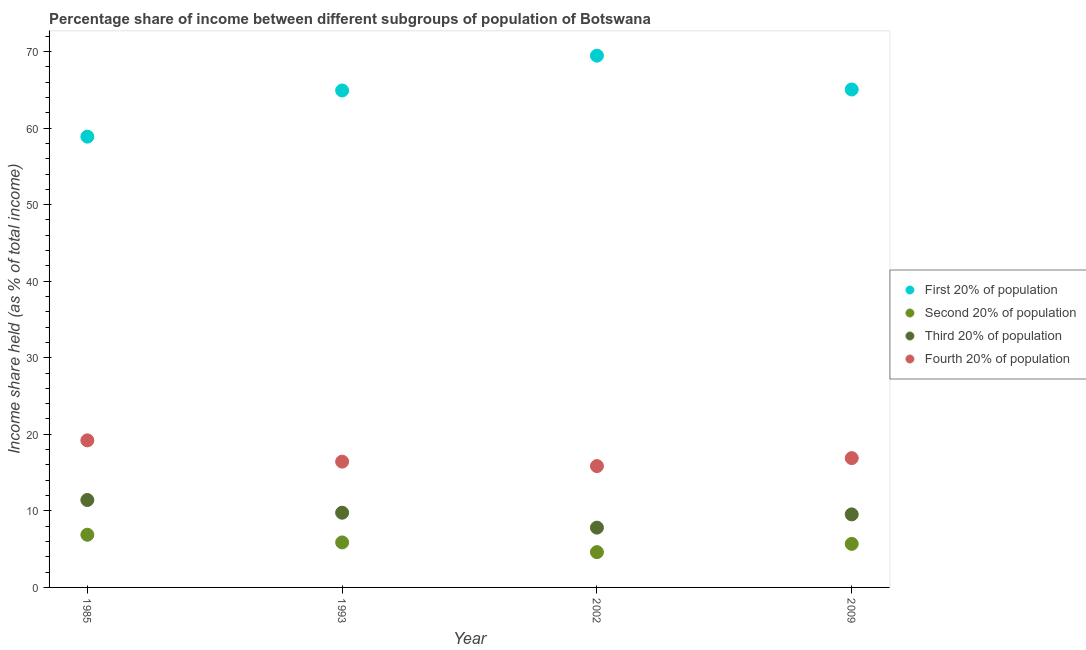Is the number of dotlines equal to the number of legend labels?
Your answer should be very brief. Yes. What is the share of the income held by first 20% of the population in 2002?
Offer a terse response. 69.46. Across all years, what is the maximum share of the income held by second 20% of the population?
Provide a short and direct response. 6.88. Across all years, what is the minimum share of the income held by first 20% of the population?
Offer a terse response. 58.88. In which year was the share of the income held by second 20% of the population maximum?
Keep it short and to the point. 1985. What is the total share of the income held by fourth 20% of the population in the graph?
Give a very brief answer. 68.38. What is the difference between the share of the income held by third 20% of the population in 1993 and that in 2002?
Your response must be concise. 1.95. What is the difference between the share of the income held by fourth 20% of the population in 1993 and the share of the income held by first 20% of the population in 2002?
Keep it short and to the point. -53.03. What is the average share of the income held by fourth 20% of the population per year?
Ensure brevity in your answer.  17.09. In the year 1985, what is the difference between the share of the income held by first 20% of the population and share of the income held by fourth 20% of the population?
Offer a terse response. 39.67. In how many years, is the share of the income held by third 20% of the population greater than 18 %?
Your answer should be compact. 0. What is the ratio of the share of the income held by third 20% of the population in 1985 to that in 1993?
Give a very brief answer. 1.17. What is the difference between the highest and the lowest share of the income held by second 20% of the population?
Your answer should be very brief. 2.27. In how many years, is the share of the income held by third 20% of the population greater than the average share of the income held by third 20% of the population taken over all years?
Your answer should be compact. 2. Is it the case that in every year, the sum of the share of the income held by first 20% of the population and share of the income held by second 20% of the population is greater than the share of the income held by third 20% of the population?
Provide a short and direct response. Yes. Does the share of the income held by first 20% of the population monotonically increase over the years?
Offer a very short reply. No. Is the share of the income held by first 20% of the population strictly greater than the share of the income held by third 20% of the population over the years?
Keep it short and to the point. Yes. What is the difference between two consecutive major ticks on the Y-axis?
Provide a succinct answer. 10. Does the graph contain any zero values?
Ensure brevity in your answer.  No. How many legend labels are there?
Your response must be concise. 4. How are the legend labels stacked?
Make the answer very short. Vertical. What is the title of the graph?
Keep it short and to the point. Percentage share of income between different subgroups of population of Botswana. Does "Taxes on revenue" appear as one of the legend labels in the graph?
Make the answer very short. No. What is the label or title of the Y-axis?
Keep it short and to the point. Income share held (as % of total income). What is the Income share held (as % of total income) of First 20% of population in 1985?
Your answer should be compact. 58.88. What is the Income share held (as % of total income) of Second 20% of population in 1985?
Your answer should be very brief. 6.88. What is the Income share held (as % of total income) in Third 20% of population in 1985?
Keep it short and to the point. 11.42. What is the Income share held (as % of total income) of Fourth 20% of population in 1985?
Your answer should be compact. 19.21. What is the Income share held (as % of total income) in First 20% of population in 1993?
Provide a short and direct response. 64.91. What is the Income share held (as % of total income) of Second 20% of population in 1993?
Your answer should be compact. 5.88. What is the Income share held (as % of total income) of Third 20% of population in 1993?
Provide a succinct answer. 9.76. What is the Income share held (as % of total income) in Fourth 20% of population in 1993?
Your response must be concise. 16.43. What is the Income share held (as % of total income) in First 20% of population in 2002?
Offer a terse response. 69.46. What is the Income share held (as % of total income) in Second 20% of population in 2002?
Your answer should be compact. 4.61. What is the Income share held (as % of total income) in Third 20% of population in 2002?
Make the answer very short. 7.81. What is the Income share held (as % of total income) of Fourth 20% of population in 2002?
Offer a terse response. 15.85. What is the Income share held (as % of total income) in First 20% of population in 2009?
Keep it short and to the point. 65.04. What is the Income share held (as % of total income) in Second 20% of population in 2009?
Provide a short and direct response. 5.69. What is the Income share held (as % of total income) in Third 20% of population in 2009?
Give a very brief answer. 9.54. What is the Income share held (as % of total income) of Fourth 20% of population in 2009?
Make the answer very short. 16.89. Across all years, what is the maximum Income share held (as % of total income) in First 20% of population?
Offer a very short reply. 69.46. Across all years, what is the maximum Income share held (as % of total income) of Second 20% of population?
Make the answer very short. 6.88. Across all years, what is the maximum Income share held (as % of total income) of Third 20% of population?
Your answer should be very brief. 11.42. Across all years, what is the maximum Income share held (as % of total income) of Fourth 20% of population?
Keep it short and to the point. 19.21. Across all years, what is the minimum Income share held (as % of total income) of First 20% of population?
Ensure brevity in your answer.  58.88. Across all years, what is the minimum Income share held (as % of total income) of Second 20% of population?
Provide a succinct answer. 4.61. Across all years, what is the minimum Income share held (as % of total income) of Third 20% of population?
Your answer should be compact. 7.81. Across all years, what is the minimum Income share held (as % of total income) in Fourth 20% of population?
Give a very brief answer. 15.85. What is the total Income share held (as % of total income) of First 20% of population in the graph?
Your answer should be very brief. 258.29. What is the total Income share held (as % of total income) in Second 20% of population in the graph?
Make the answer very short. 23.06. What is the total Income share held (as % of total income) of Third 20% of population in the graph?
Give a very brief answer. 38.53. What is the total Income share held (as % of total income) in Fourth 20% of population in the graph?
Your response must be concise. 68.38. What is the difference between the Income share held (as % of total income) of First 20% of population in 1985 and that in 1993?
Your answer should be very brief. -6.03. What is the difference between the Income share held (as % of total income) of Second 20% of population in 1985 and that in 1993?
Provide a succinct answer. 1. What is the difference between the Income share held (as % of total income) of Third 20% of population in 1985 and that in 1993?
Ensure brevity in your answer.  1.66. What is the difference between the Income share held (as % of total income) of Fourth 20% of population in 1985 and that in 1993?
Keep it short and to the point. 2.78. What is the difference between the Income share held (as % of total income) in First 20% of population in 1985 and that in 2002?
Your answer should be compact. -10.58. What is the difference between the Income share held (as % of total income) of Second 20% of population in 1985 and that in 2002?
Give a very brief answer. 2.27. What is the difference between the Income share held (as % of total income) in Third 20% of population in 1985 and that in 2002?
Your response must be concise. 3.61. What is the difference between the Income share held (as % of total income) of Fourth 20% of population in 1985 and that in 2002?
Make the answer very short. 3.36. What is the difference between the Income share held (as % of total income) in First 20% of population in 1985 and that in 2009?
Your answer should be compact. -6.16. What is the difference between the Income share held (as % of total income) in Second 20% of population in 1985 and that in 2009?
Your answer should be very brief. 1.19. What is the difference between the Income share held (as % of total income) in Third 20% of population in 1985 and that in 2009?
Your answer should be very brief. 1.88. What is the difference between the Income share held (as % of total income) of Fourth 20% of population in 1985 and that in 2009?
Your answer should be compact. 2.32. What is the difference between the Income share held (as % of total income) in First 20% of population in 1993 and that in 2002?
Your response must be concise. -4.55. What is the difference between the Income share held (as % of total income) in Second 20% of population in 1993 and that in 2002?
Your answer should be very brief. 1.27. What is the difference between the Income share held (as % of total income) in Third 20% of population in 1993 and that in 2002?
Offer a terse response. 1.95. What is the difference between the Income share held (as % of total income) of Fourth 20% of population in 1993 and that in 2002?
Offer a very short reply. 0.58. What is the difference between the Income share held (as % of total income) in First 20% of population in 1993 and that in 2009?
Keep it short and to the point. -0.13. What is the difference between the Income share held (as % of total income) of Second 20% of population in 1993 and that in 2009?
Make the answer very short. 0.19. What is the difference between the Income share held (as % of total income) in Third 20% of population in 1993 and that in 2009?
Keep it short and to the point. 0.22. What is the difference between the Income share held (as % of total income) in Fourth 20% of population in 1993 and that in 2009?
Provide a succinct answer. -0.46. What is the difference between the Income share held (as % of total income) in First 20% of population in 2002 and that in 2009?
Your response must be concise. 4.42. What is the difference between the Income share held (as % of total income) in Second 20% of population in 2002 and that in 2009?
Ensure brevity in your answer.  -1.08. What is the difference between the Income share held (as % of total income) in Third 20% of population in 2002 and that in 2009?
Offer a terse response. -1.73. What is the difference between the Income share held (as % of total income) of Fourth 20% of population in 2002 and that in 2009?
Keep it short and to the point. -1.04. What is the difference between the Income share held (as % of total income) of First 20% of population in 1985 and the Income share held (as % of total income) of Second 20% of population in 1993?
Your answer should be very brief. 53. What is the difference between the Income share held (as % of total income) in First 20% of population in 1985 and the Income share held (as % of total income) in Third 20% of population in 1993?
Provide a short and direct response. 49.12. What is the difference between the Income share held (as % of total income) in First 20% of population in 1985 and the Income share held (as % of total income) in Fourth 20% of population in 1993?
Offer a terse response. 42.45. What is the difference between the Income share held (as % of total income) of Second 20% of population in 1985 and the Income share held (as % of total income) of Third 20% of population in 1993?
Offer a very short reply. -2.88. What is the difference between the Income share held (as % of total income) of Second 20% of population in 1985 and the Income share held (as % of total income) of Fourth 20% of population in 1993?
Provide a succinct answer. -9.55. What is the difference between the Income share held (as % of total income) of Third 20% of population in 1985 and the Income share held (as % of total income) of Fourth 20% of population in 1993?
Provide a succinct answer. -5.01. What is the difference between the Income share held (as % of total income) of First 20% of population in 1985 and the Income share held (as % of total income) of Second 20% of population in 2002?
Make the answer very short. 54.27. What is the difference between the Income share held (as % of total income) of First 20% of population in 1985 and the Income share held (as % of total income) of Third 20% of population in 2002?
Keep it short and to the point. 51.07. What is the difference between the Income share held (as % of total income) of First 20% of population in 1985 and the Income share held (as % of total income) of Fourth 20% of population in 2002?
Ensure brevity in your answer.  43.03. What is the difference between the Income share held (as % of total income) of Second 20% of population in 1985 and the Income share held (as % of total income) of Third 20% of population in 2002?
Keep it short and to the point. -0.93. What is the difference between the Income share held (as % of total income) in Second 20% of population in 1985 and the Income share held (as % of total income) in Fourth 20% of population in 2002?
Your answer should be compact. -8.97. What is the difference between the Income share held (as % of total income) in Third 20% of population in 1985 and the Income share held (as % of total income) in Fourth 20% of population in 2002?
Offer a very short reply. -4.43. What is the difference between the Income share held (as % of total income) in First 20% of population in 1985 and the Income share held (as % of total income) in Second 20% of population in 2009?
Ensure brevity in your answer.  53.19. What is the difference between the Income share held (as % of total income) in First 20% of population in 1985 and the Income share held (as % of total income) in Third 20% of population in 2009?
Your answer should be compact. 49.34. What is the difference between the Income share held (as % of total income) in First 20% of population in 1985 and the Income share held (as % of total income) in Fourth 20% of population in 2009?
Give a very brief answer. 41.99. What is the difference between the Income share held (as % of total income) of Second 20% of population in 1985 and the Income share held (as % of total income) of Third 20% of population in 2009?
Give a very brief answer. -2.66. What is the difference between the Income share held (as % of total income) in Second 20% of population in 1985 and the Income share held (as % of total income) in Fourth 20% of population in 2009?
Keep it short and to the point. -10.01. What is the difference between the Income share held (as % of total income) in Third 20% of population in 1985 and the Income share held (as % of total income) in Fourth 20% of population in 2009?
Keep it short and to the point. -5.47. What is the difference between the Income share held (as % of total income) of First 20% of population in 1993 and the Income share held (as % of total income) of Second 20% of population in 2002?
Ensure brevity in your answer.  60.3. What is the difference between the Income share held (as % of total income) in First 20% of population in 1993 and the Income share held (as % of total income) in Third 20% of population in 2002?
Your response must be concise. 57.1. What is the difference between the Income share held (as % of total income) in First 20% of population in 1993 and the Income share held (as % of total income) in Fourth 20% of population in 2002?
Your answer should be compact. 49.06. What is the difference between the Income share held (as % of total income) in Second 20% of population in 1993 and the Income share held (as % of total income) in Third 20% of population in 2002?
Your response must be concise. -1.93. What is the difference between the Income share held (as % of total income) of Second 20% of population in 1993 and the Income share held (as % of total income) of Fourth 20% of population in 2002?
Provide a succinct answer. -9.97. What is the difference between the Income share held (as % of total income) of Third 20% of population in 1993 and the Income share held (as % of total income) of Fourth 20% of population in 2002?
Your response must be concise. -6.09. What is the difference between the Income share held (as % of total income) in First 20% of population in 1993 and the Income share held (as % of total income) in Second 20% of population in 2009?
Your answer should be compact. 59.22. What is the difference between the Income share held (as % of total income) in First 20% of population in 1993 and the Income share held (as % of total income) in Third 20% of population in 2009?
Provide a short and direct response. 55.37. What is the difference between the Income share held (as % of total income) in First 20% of population in 1993 and the Income share held (as % of total income) in Fourth 20% of population in 2009?
Your answer should be compact. 48.02. What is the difference between the Income share held (as % of total income) of Second 20% of population in 1993 and the Income share held (as % of total income) of Third 20% of population in 2009?
Offer a terse response. -3.66. What is the difference between the Income share held (as % of total income) in Second 20% of population in 1993 and the Income share held (as % of total income) in Fourth 20% of population in 2009?
Provide a succinct answer. -11.01. What is the difference between the Income share held (as % of total income) in Third 20% of population in 1993 and the Income share held (as % of total income) in Fourth 20% of population in 2009?
Keep it short and to the point. -7.13. What is the difference between the Income share held (as % of total income) in First 20% of population in 2002 and the Income share held (as % of total income) in Second 20% of population in 2009?
Your response must be concise. 63.77. What is the difference between the Income share held (as % of total income) of First 20% of population in 2002 and the Income share held (as % of total income) of Third 20% of population in 2009?
Ensure brevity in your answer.  59.92. What is the difference between the Income share held (as % of total income) of First 20% of population in 2002 and the Income share held (as % of total income) of Fourth 20% of population in 2009?
Offer a terse response. 52.57. What is the difference between the Income share held (as % of total income) of Second 20% of population in 2002 and the Income share held (as % of total income) of Third 20% of population in 2009?
Keep it short and to the point. -4.93. What is the difference between the Income share held (as % of total income) in Second 20% of population in 2002 and the Income share held (as % of total income) in Fourth 20% of population in 2009?
Offer a very short reply. -12.28. What is the difference between the Income share held (as % of total income) of Third 20% of population in 2002 and the Income share held (as % of total income) of Fourth 20% of population in 2009?
Provide a succinct answer. -9.08. What is the average Income share held (as % of total income) of First 20% of population per year?
Provide a short and direct response. 64.57. What is the average Income share held (as % of total income) in Second 20% of population per year?
Keep it short and to the point. 5.76. What is the average Income share held (as % of total income) of Third 20% of population per year?
Make the answer very short. 9.63. What is the average Income share held (as % of total income) in Fourth 20% of population per year?
Offer a very short reply. 17.09. In the year 1985, what is the difference between the Income share held (as % of total income) in First 20% of population and Income share held (as % of total income) in Second 20% of population?
Provide a short and direct response. 52. In the year 1985, what is the difference between the Income share held (as % of total income) in First 20% of population and Income share held (as % of total income) in Third 20% of population?
Provide a short and direct response. 47.46. In the year 1985, what is the difference between the Income share held (as % of total income) of First 20% of population and Income share held (as % of total income) of Fourth 20% of population?
Give a very brief answer. 39.67. In the year 1985, what is the difference between the Income share held (as % of total income) in Second 20% of population and Income share held (as % of total income) in Third 20% of population?
Your response must be concise. -4.54. In the year 1985, what is the difference between the Income share held (as % of total income) of Second 20% of population and Income share held (as % of total income) of Fourth 20% of population?
Your response must be concise. -12.33. In the year 1985, what is the difference between the Income share held (as % of total income) of Third 20% of population and Income share held (as % of total income) of Fourth 20% of population?
Make the answer very short. -7.79. In the year 1993, what is the difference between the Income share held (as % of total income) in First 20% of population and Income share held (as % of total income) in Second 20% of population?
Keep it short and to the point. 59.03. In the year 1993, what is the difference between the Income share held (as % of total income) in First 20% of population and Income share held (as % of total income) in Third 20% of population?
Give a very brief answer. 55.15. In the year 1993, what is the difference between the Income share held (as % of total income) of First 20% of population and Income share held (as % of total income) of Fourth 20% of population?
Provide a short and direct response. 48.48. In the year 1993, what is the difference between the Income share held (as % of total income) of Second 20% of population and Income share held (as % of total income) of Third 20% of population?
Offer a very short reply. -3.88. In the year 1993, what is the difference between the Income share held (as % of total income) of Second 20% of population and Income share held (as % of total income) of Fourth 20% of population?
Your answer should be very brief. -10.55. In the year 1993, what is the difference between the Income share held (as % of total income) of Third 20% of population and Income share held (as % of total income) of Fourth 20% of population?
Keep it short and to the point. -6.67. In the year 2002, what is the difference between the Income share held (as % of total income) in First 20% of population and Income share held (as % of total income) in Second 20% of population?
Offer a very short reply. 64.85. In the year 2002, what is the difference between the Income share held (as % of total income) in First 20% of population and Income share held (as % of total income) in Third 20% of population?
Ensure brevity in your answer.  61.65. In the year 2002, what is the difference between the Income share held (as % of total income) of First 20% of population and Income share held (as % of total income) of Fourth 20% of population?
Give a very brief answer. 53.61. In the year 2002, what is the difference between the Income share held (as % of total income) in Second 20% of population and Income share held (as % of total income) in Third 20% of population?
Your answer should be very brief. -3.2. In the year 2002, what is the difference between the Income share held (as % of total income) in Second 20% of population and Income share held (as % of total income) in Fourth 20% of population?
Offer a very short reply. -11.24. In the year 2002, what is the difference between the Income share held (as % of total income) of Third 20% of population and Income share held (as % of total income) of Fourth 20% of population?
Provide a short and direct response. -8.04. In the year 2009, what is the difference between the Income share held (as % of total income) of First 20% of population and Income share held (as % of total income) of Second 20% of population?
Make the answer very short. 59.35. In the year 2009, what is the difference between the Income share held (as % of total income) of First 20% of population and Income share held (as % of total income) of Third 20% of population?
Ensure brevity in your answer.  55.5. In the year 2009, what is the difference between the Income share held (as % of total income) in First 20% of population and Income share held (as % of total income) in Fourth 20% of population?
Provide a succinct answer. 48.15. In the year 2009, what is the difference between the Income share held (as % of total income) in Second 20% of population and Income share held (as % of total income) in Third 20% of population?
Your response must be concise. -3.85. In the year 2009, what is the difference between the Income share held (as % of total income) of Third 20% of population and Income share held (as % of total income) of Fourth 20% of population?
Your answer should be compact. -7.35. What is the ratio of the Income share held (as % of total income) of First 20% of population in 1985 to that in 1993?
Offer a very short reply. 0.91. What is the ratio of the Income share held (as % of total income) in Second 20% of population in 1985 to that in 1993?
Provide a short and direct response. 1.17. What is the ratio of the Income share held (as % of total income) in Third 20% of population in 1985 to that in 1993?
Your answer should be compact. 1.17. What is the ratio of the Income share held (as % of total income) of Fourth 20% of population in 1985 to that in 1993?
Offer a very short reply. 1.17. What is the ratio of the Income share held (as % of total income) of First 20% of population in 1985 to that in 2002?
Keep it short and to the point. 0.85. What is the ratio of the Income share held (as % of total income) of Second 20% of population in 1985 to that in 2002?
Provide a succinct answer. 1.49. What is the ratio of the Income share held (as % of total income) in Third 20% of population in 1985 to that in 2002?
Ensure brevity in your answer.  1.46. What is the ratio of the Income share held (as % of total income) in Fourth 20% of population in 1985 to that in 2002?
Your response must be concise. 1.21. What is the ratio of the Income share held (as % of total income) of First 20% of population in 1985 to that in 2009?
Your answer should be compact. 0.91. What is the ratio of the Income share held (as % of total income) of Second 20% of population in 1985 to that in 2009?
Provide a short and direct response. 1.21. What is the ratio of the Income share held (as % of total income) in Third 20% of population in 1985 to that in 2009?
Make the answer very short. 1.2. What is the ratio of the Income share held (as % of total income) in Fourth 20% of population in 1985 to that in 2009?
Provide a succinct answer. 1.14. What is the ratio of the Income share held (as % of total income) in First 20% of population in 1993 to that in 2002?
Give a very brief answer. 0.93. What is the ratio of the Income share held (as % of total income) in Second 20% of population in 1993 to that in 2002?
Provide a succinct answer. 1.28. What is the ratio of the Income share held (as % of total income) of Third 20% of population in 1993 to that in 2002?
Offer a very short reply. 1.25. What is the ratio of the Income share held (as % of total income) in Fourth 20% of population in 1993 to that in 2002?
Provide a short and direct response. 1.04. What is the ratio of the Income share held (as % of total income) of First 20% of population in 1993 to that in 2009?
Keep it short and to the point. 1. What is the ratio of the Income share held (as % of total income) of Second 20% of population in 1993 to that in 2009?
Provide a short and direct response. 1.03. What is the ratio of the Income share held (as % of total income) in Third 20% of population in 1993 to that in 2009?
Offer a terse response. 1.02. What is the ratio of the Income share held (as % of total income) in Fourth 20% of population in 1993 to that in 2009?
Ensure brevity in your answer.  0.97. What is the ratio of the Income share held (as % of total income) of First 20% of population in 2002 to that in 2009?
Offer a terse response. 1.07. What is the ratio of the Income share held (as % of total income) of Second 20% of population in 2002 to that in 2009?
Keep it short and to the point. 0.81. What is the ratio of the Income share held (as % of total income) in Third 20% of population in 2002 to that in 2009?
Provide a succinct answer. 0.82. What is the ratio of the Income share held (as % of total income) in Fourth 20% of population in 2002 to that in 2009?
Your response must be concise. 0.94. What is the difference between the highest and the second highest Income share held (as % of total income) in First 20% of population?
Your answer should be compact. 4.42. What is the difference between the highest and the second highest Income share held (as % of total income) in Third 20% of population?
Make the answer very short. 1.66. What is the difference between the highest and the second highest Income share held (as % of total income) in Fourth 20% of population?
Your answer should be very brief. 2.32. What is the difference between the highest and the lowest Income share held (as % of total income) of First 20% of population?
Keep it short and to the point. 10.58. What is the difference between the highest and the lowest Income share held (as % of total income) in Second 20% of population?
Give a very brief answer. 2.27. What is the difference between the highest and the lowest Income share held (as % of total income) in Third 20% of population?
Your answer should be very brief. 3.61. What is the difference between the highest and the lowest Income share held (as % of total income) of Fourth 20% of population?
Give a very brief answer. 3.36. 